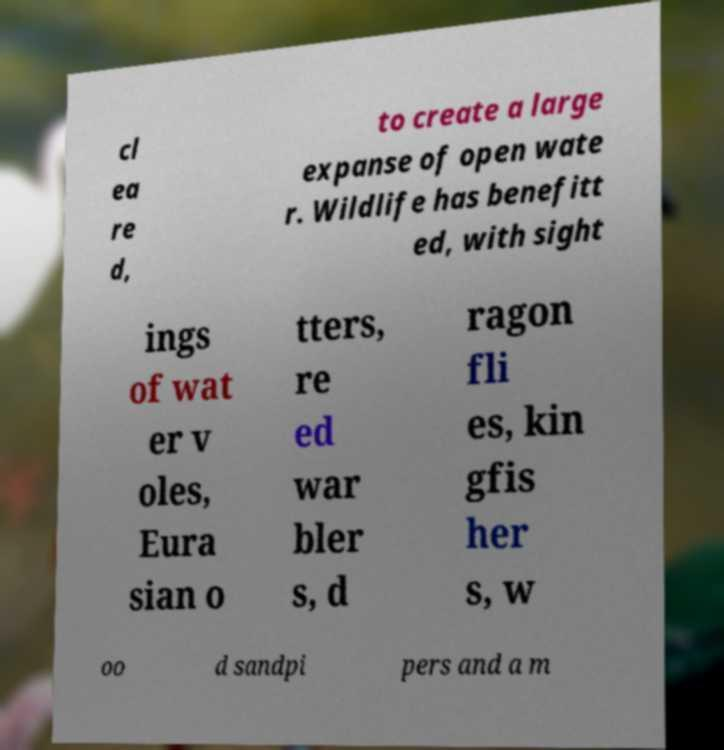There's text embedded in this image that I need extracted. Can you transcribe it verbatim? cl ea re d, to create a large expanse of open wate r. Wildlife has benefitt ed, with sight ings of wat er v oles, Eura sian o tters, re ed war bler s, d ragon fli es, kin gfis her s, w oo d sandpi pers and a m 